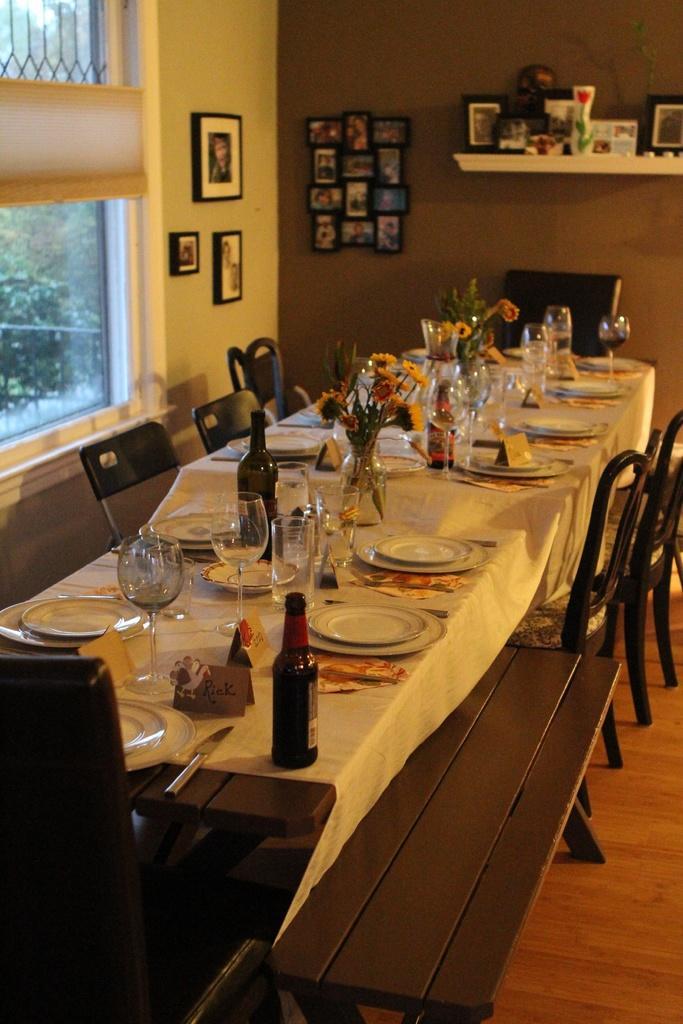Could you give a brief overview of what you see in this image? In this picture we can see a bench, chairs on the floor, tables with a white cloth, plates, glasses, bottles, name cards, flower vases, knives on it and in the background we can see windows, rack, frames on walls and some objects. 